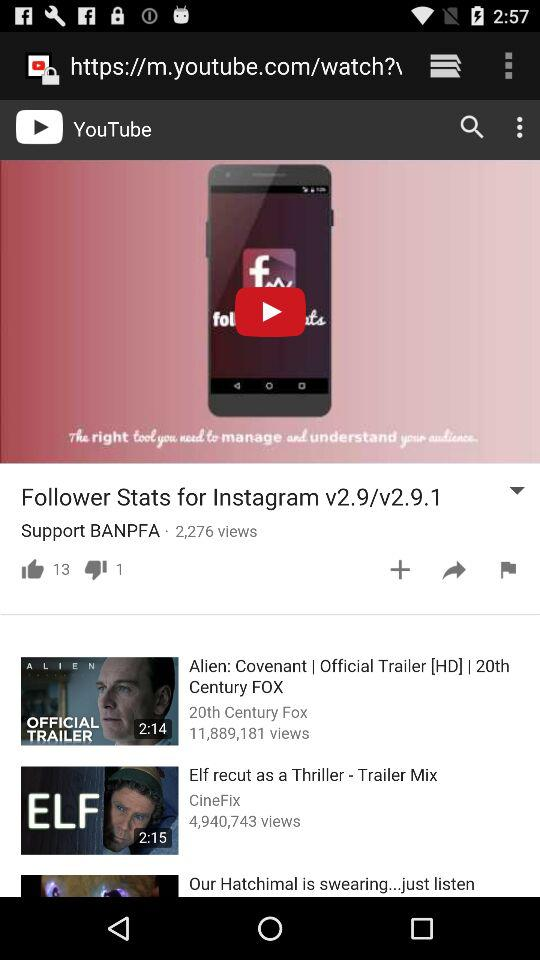How many more thumbs up than thumbs down are there?
Answer the question using a single word or phrase. 12 